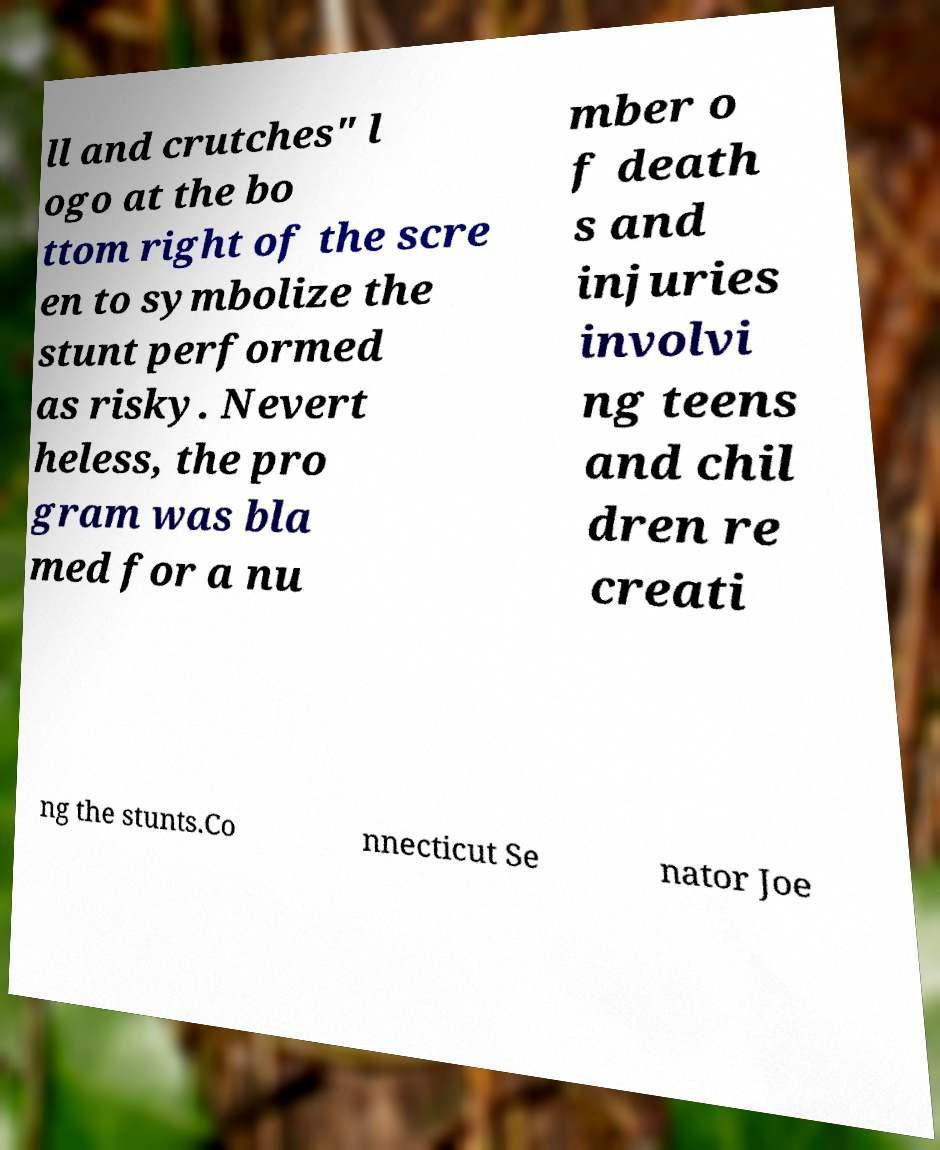What messages or text are displayed in this image? I need them in a readable, typed format. ll and crutches" l ogo at the bo ttom right of the scre en to symbolize the stunt performed as risky. Nevert heless, the pro gram was bla med for a nu mber o f death s and injuries involvi ng teens and chil dren re creati ng the stunts.Co nnecticut Se nator Joe 